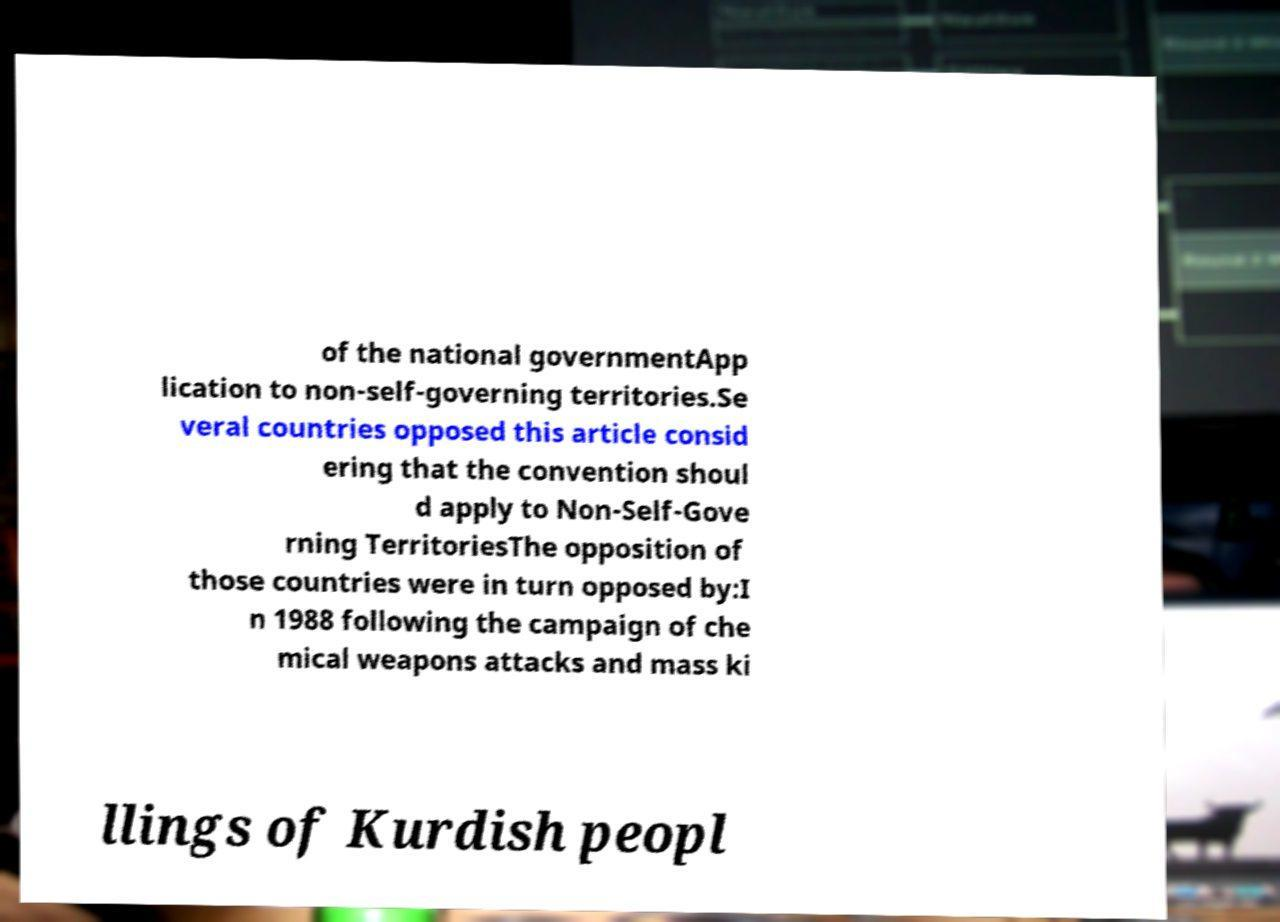Please read and relay the text visible in this image. What does it say? of the national governmentApp lication to non-self-governing territories.Se veral countries opposed this article consid ering that the convention shoul d apply to Non-Self-Gove rning TerritoriesThe opposition of those countries were in turn opposed by:I n 1988 following the campaign of che mical weapons attacks and mass ki llings of Kurdish peopl 